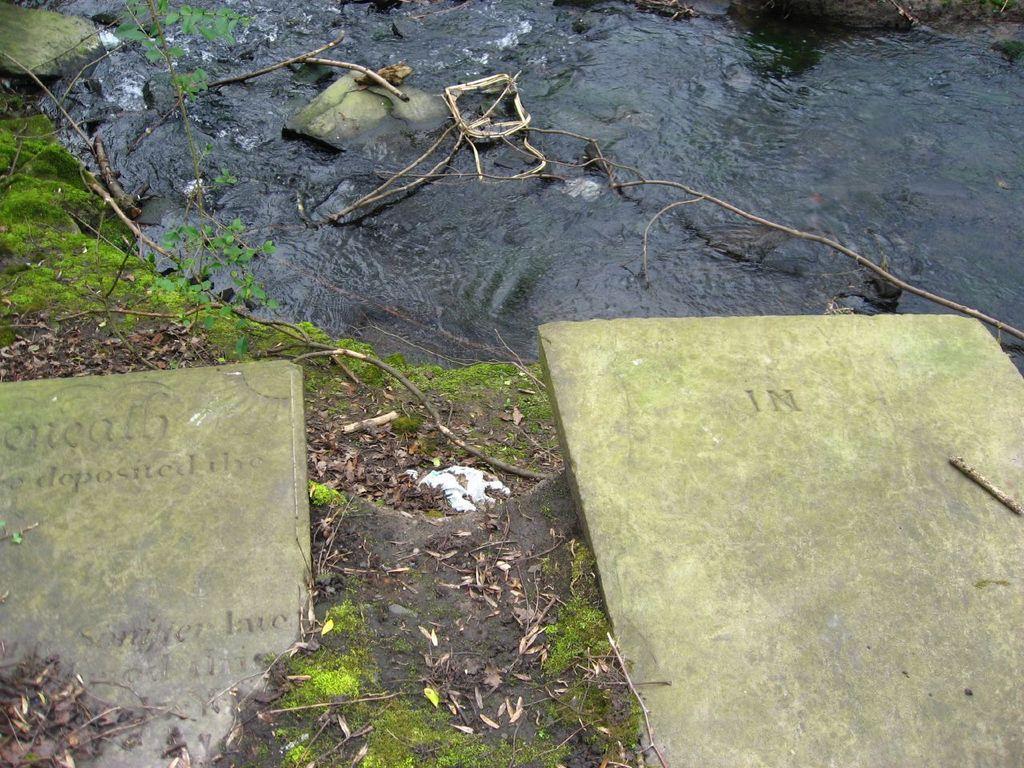Describe this image in one or two sentences. As we can see in the image there is water and stones. 